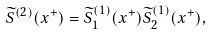Convert formula to latex. <formula><loc_0><loc_0><loc_500><loc_500>\widetilde { S } ^ { ( 2 ) } ( x ^ { + } ) = \widetilde { S } _ { 1 } ^ { ( 1 ) } ( x ^ { + } ) \widetilde { S } _ { 2 } ^ { ( 1 ) } ( x ^ { + } ) ,</formula> 